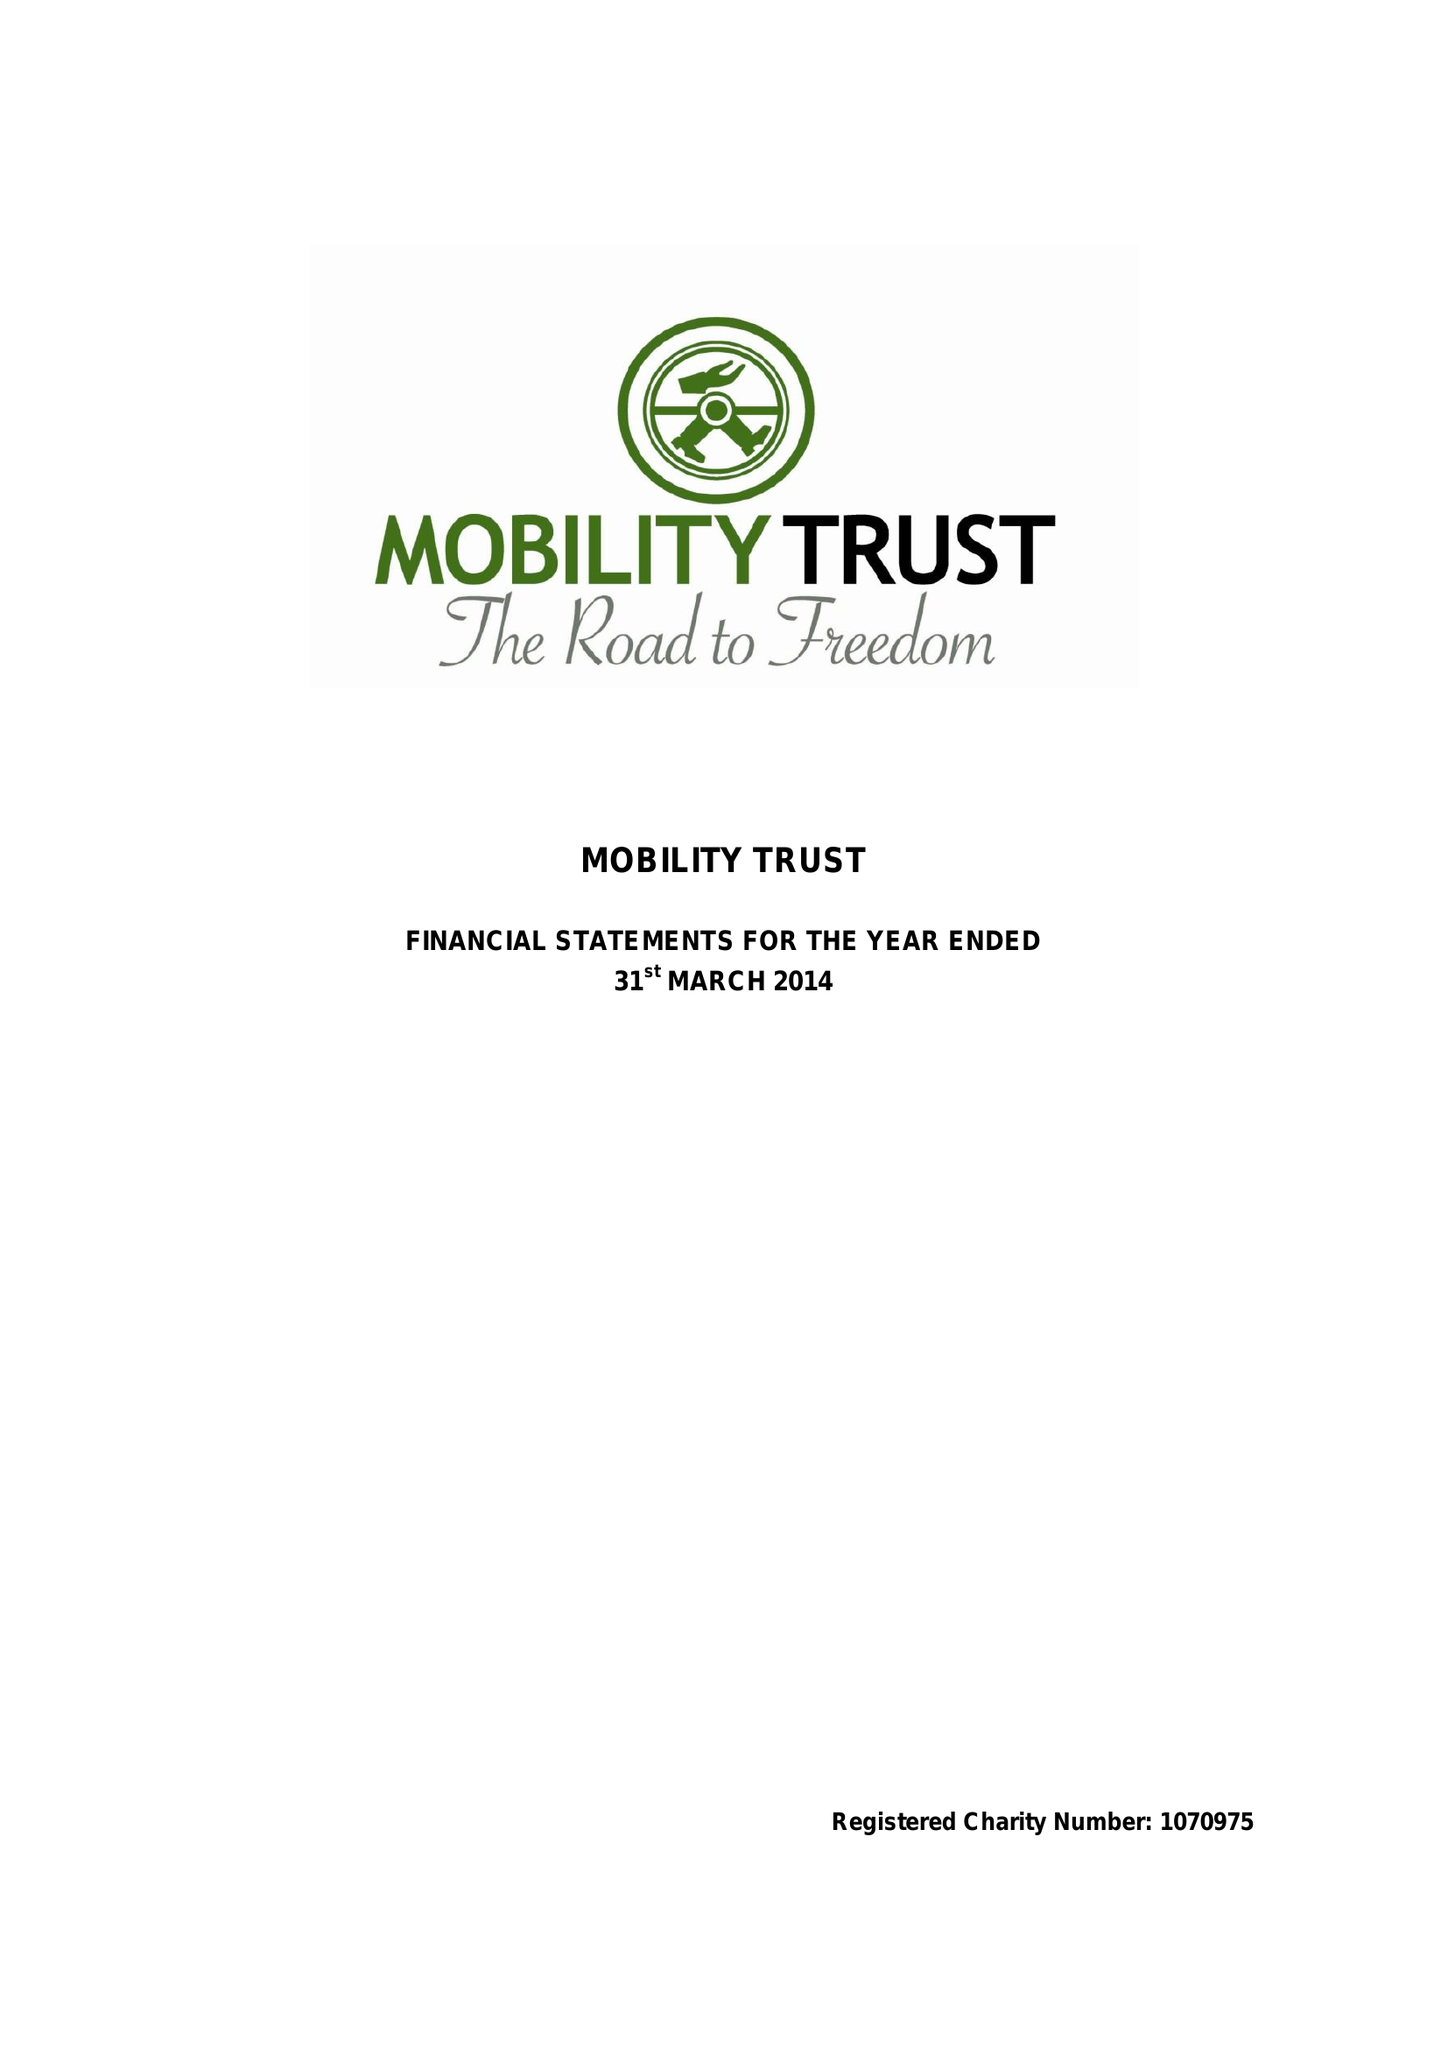What is the value for the address__street_line?
Answer the question using a single word or phrase. 19 READING ROAD 